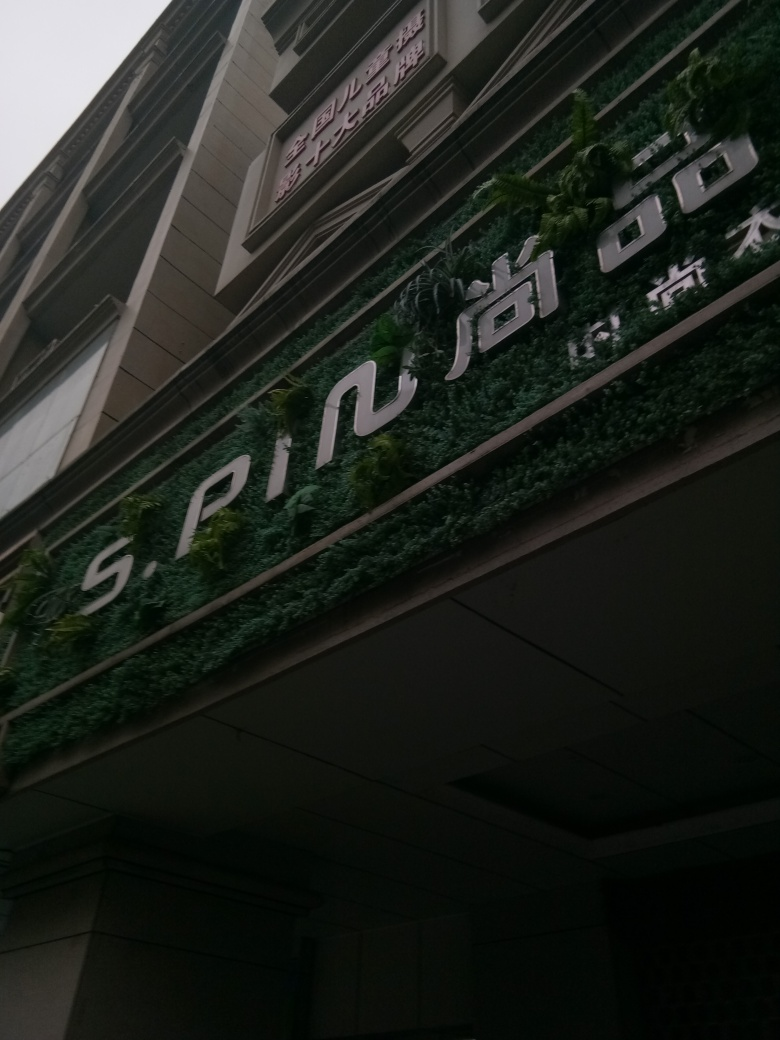Can you tell me more about the design style of the signage on the building's facade? The signage design on the building's facade appears to be modern with clean, bold lettering that stands out distinctly against the greenery of the vertical garden. The choice of white characters on a contrasting background ensures high visibility and reflects a contemporary aesthetic. 